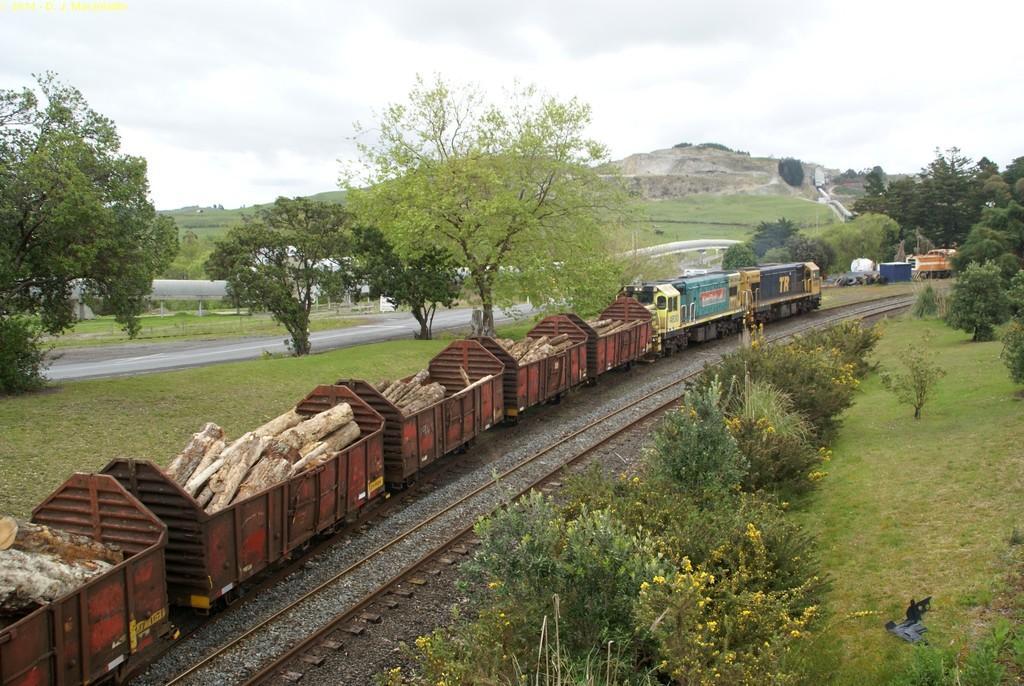Could you give a brief overview of what you see in this image? In this picture there is a goods train moving on the railway track, carrying wooden logs. There are trees here. In the background there is a hill and a sky. 